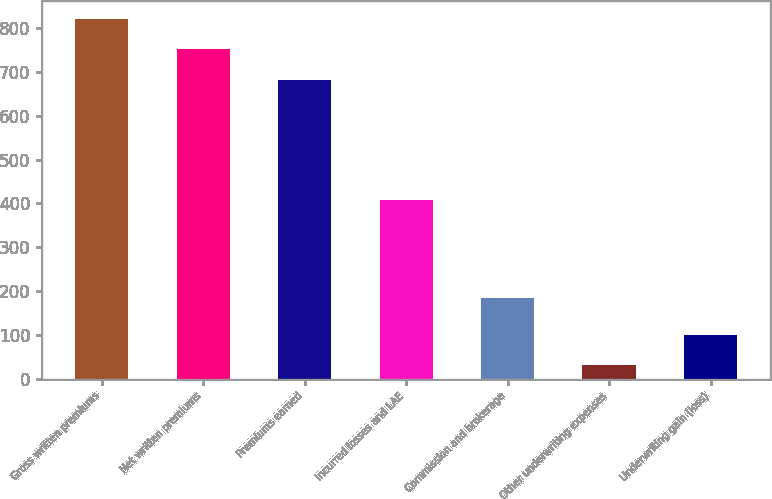<chart> <loc_0><loc_0><loc_500><loc_500><bar_chart><fcel>Gross written premiums<fcel>Net written premiums<fcel>Premiums earned<fcel>Incurred losses and LAE<fcel>Commission and brokerage<fcel>Other underwriting expenses<fcel>Underwriting gain (loss)<nl><fcel>821.66<fcel>751.28<fcel>680.9<fcel>408.2<fcel>184.4<fcel>30.6<fcel>100.98<nl></chart> 